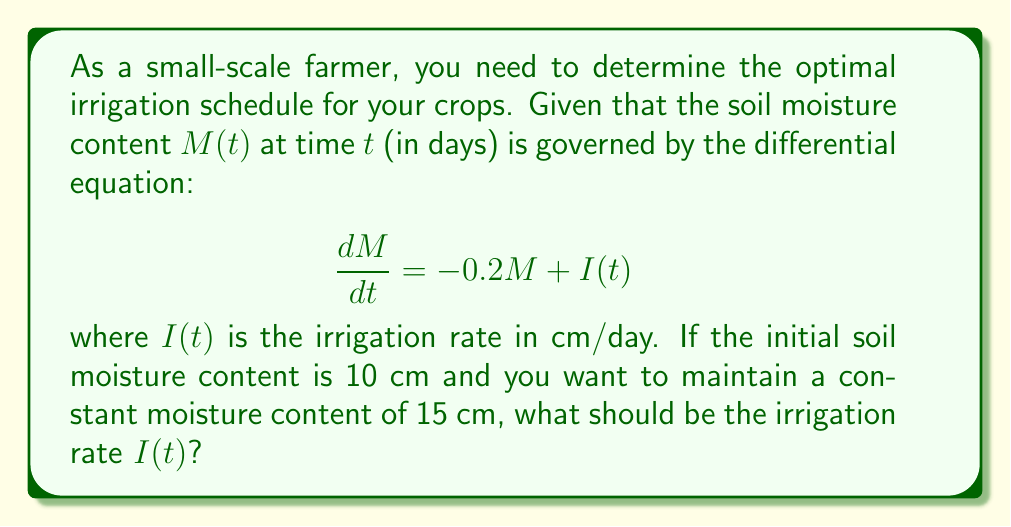Teach me how to tackle this problem. Let's solve this problem step by step:

1) We want to maintain a constant moisture content of 15 cm. This means that $\frac{dM}{dt} = 0$ and $M = 15$ at all times after reaching this level.

2) Substituting these values into the given differential equation:

   $$0 = -0.2(15) + I(t)$$

3) Solving for $I(t)$:

   $$I(t) = 0.2(15) = 3$$

4) This means that to maintain a constant moisture content of 15 cm, we need to irrigate at a constant rate of 3 cm/day.

5) However, we started with an initial moisture content of 10 cm. We need to find how long it takes to reach 15 cm.

6) The general solution to the differential equation is:

   $$M(t) = Ce^{-0.2t} + 15$$

   where $C$ is a constant determined by the initial condition.

7) Using the initial condition $M(0) = 10$:

   $$10 = C + 15$$
   $$C = -5$$

8) So the specific solution is:

   $$M(t) = 15 - 5e^{-0.2t}$$

9) To find when this reaches 15 cm, we solve:

   $$15 = 15 - 5e^{-0.2t}$$
   $$5e^{-0.2t} = 0$$

   This is true as $t$ approaches infinity, but practically, we can consider it reached when, say, $5e^{-0.2t} < 0.1$, which occurs at about $t = 15$ days.

Therefore, the optimal irrigation schedule is to irrigate at a rate of 3 cm/day, starting immediately and continuing indefinitely.
Answer: $I(t) = 3$ cm/day, starting immediately and continuing indefinitely. 